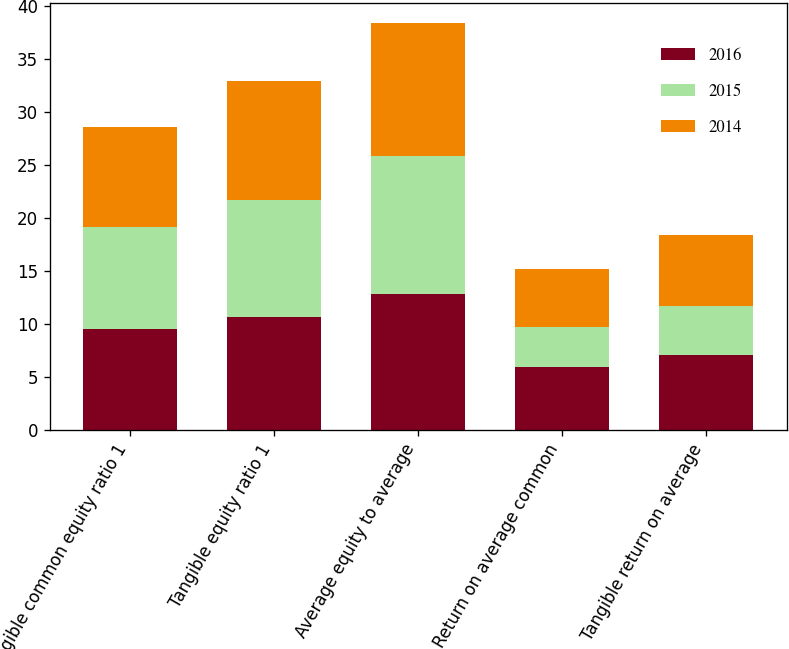Convert chart to OTSL. <chart><loc_0><loc_0><loc_500><loc_500><stacked_bar_chart><ecel><fcel>Tangible common equity ratio 1<fcel>Tangible equity ratio 1<fcel>Average equity to average<fcel>Return on average common<fcel>Tangible return on average<nl><fcel>2016<fcel>9.49<fcel>10.63<fcel>12.77<fcel>5.95<fcel>7.07<nl><fcel>2015<fcel>9.63<fcel>11.05<fcel>13.03<fcel>3.75<fcel>4.55<nl><fcel>2014<fcel>9.48<fcel>11.27<fcel>12.57<fcel>5.42<fcel>6.7<nl></chart> 